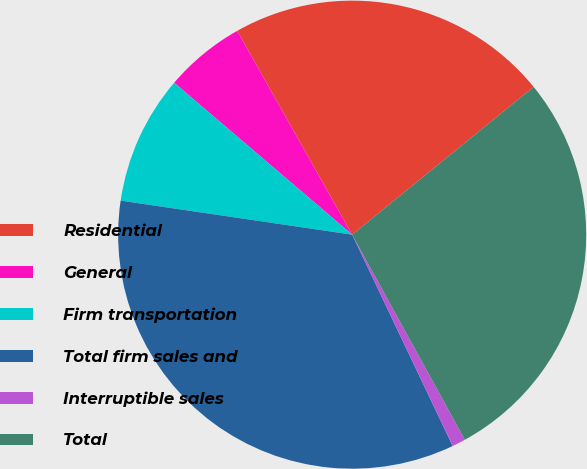Convert chart. <chart><loc_0><loc_0><loc_500><loc_500><pie_chart><fcel>Residential<fcel>General<fcel>Firm transportation<fcel>Total firm sales and<fcel>Interruptible sales<fcel>Total<nl><fcel>22.3%<fcel>5.58%<fcel>8.92%<fcel>34.39%<fcel>0.93%<fcel>27.88%<nl></chart> 